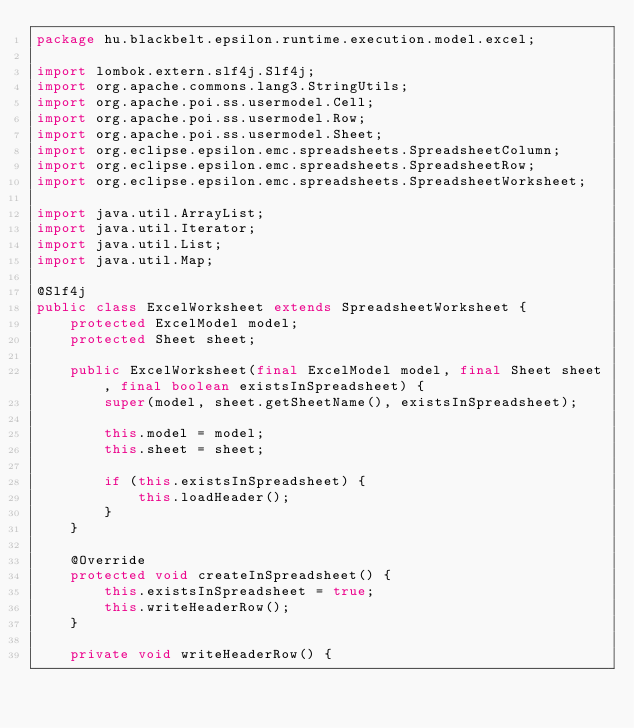<code> <loc_0><loc_0><loc_500><loc_500><_Java_>package hu.blackbelt.epsilon.runtime.execution.model.excel;

import lombok.extern.slf4j.Slf4j;
import org.apache.commons.lang3.StringUtils;
import org.apache.poi.ss.usermodel.Cell;
import org.apache.poi.ss.usermodel.Row;
import org.apache.poi.ss.usermodel.Sheet;
import org.eclipse.epsilon.emc.spreadsheets.SpreadsheetColumn;
import org.eclipse.epsilon.emc.spreadsheets.SpreadsheetRow;
import org.eclipse.epsilon.emc.spreadsheets.SpreadsheetWorksheet;

import java.util.ArrayList;
import java.util.Iterator;
import java.util.List;
import java.util.Map;

@Slf4j
public class ExcelWorksheet extends SpreadsheetWorksheet {
    protected ExcelModel model;
    protected Sheet sheet;

    public ExcelWorksheet(final ExcelModel model, final Sheet sheet, final boolean existsInSpreadsheet) {
        super(model, sheet.getSheetName(), existsInSpreadsheet);

        this.model = model;
        this.sheet = sheet;

        if (this.existsInSpreadsheet) {
            this.loadHeader();
        }
    }

    @Override
    protected void createInSpreadsheet() {
        this.existsInSpreadsheet = true;
        this.writeHeaderRow();
    }

    private void writeHeaderRow() {</code> 